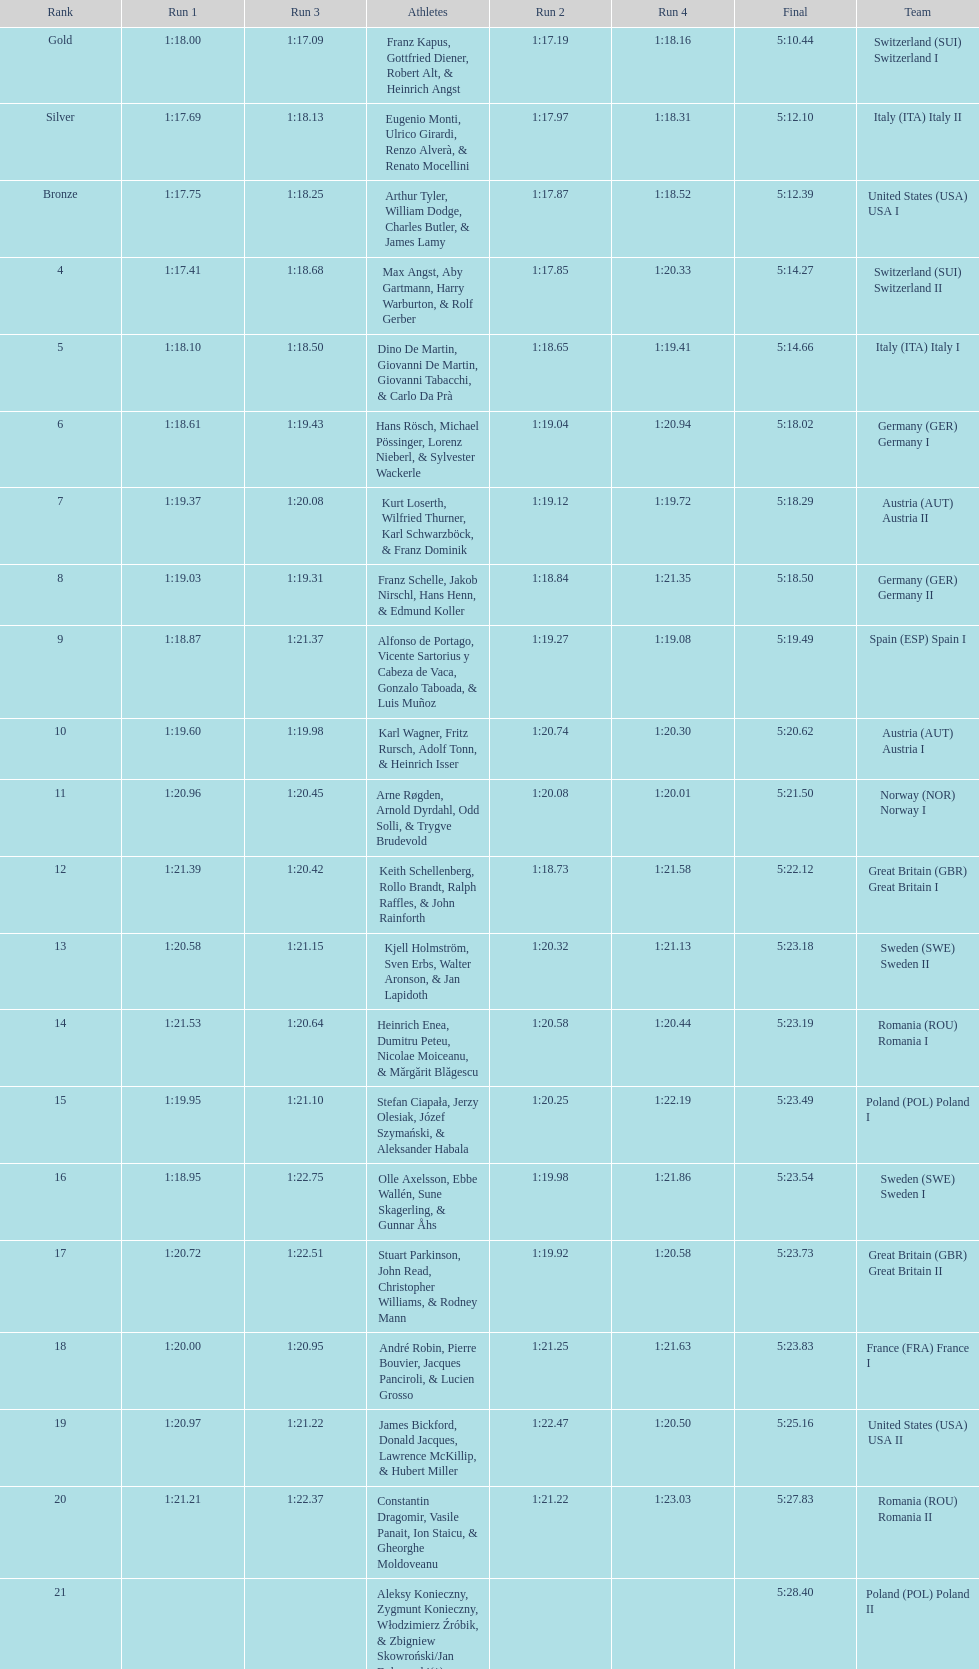Which team won the most runs? Switzerland. 